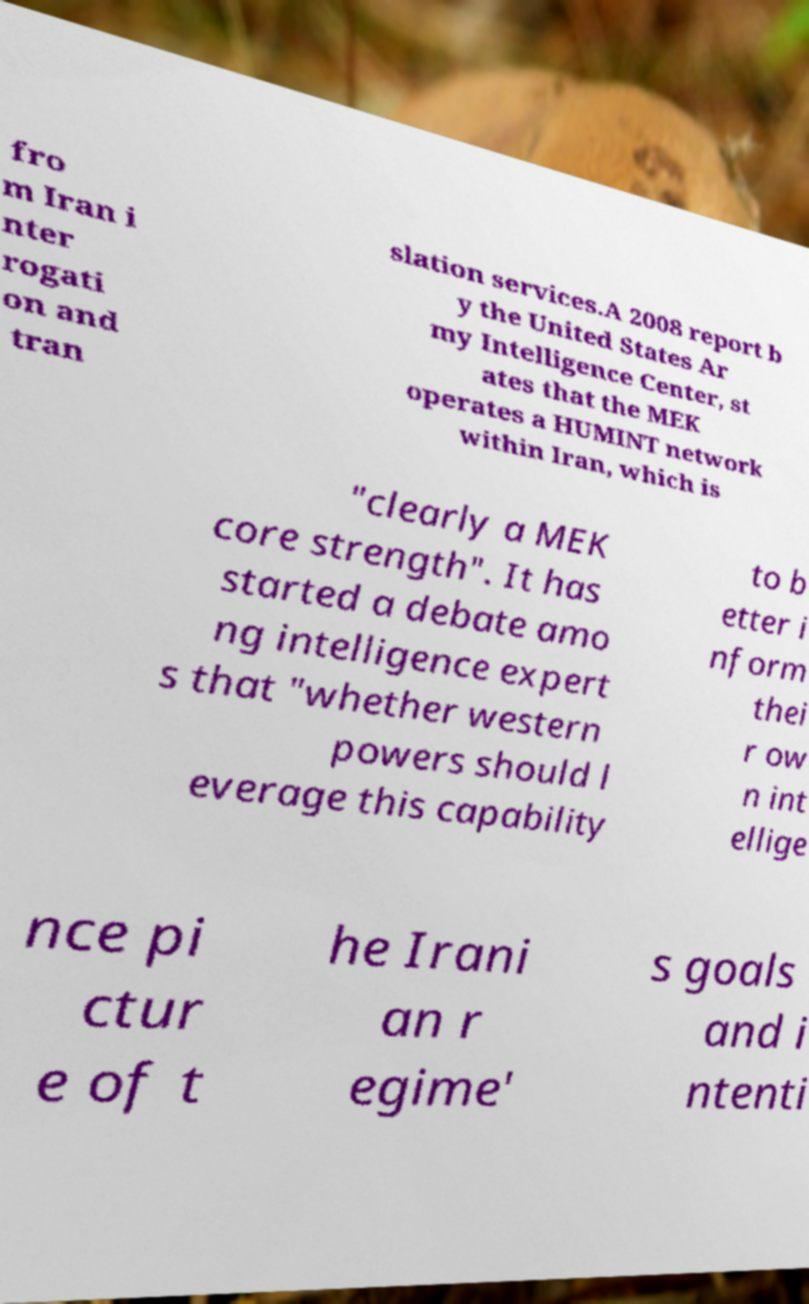I need the written content from this picture converted into text. Can you do that? fro m Iran i nter rogati on and tran slation services.A 2008 report b y the United States Ar my Intelligence Center, st ates that the MEK operates a HUMINT network within Iran, which is "clearly a MEK core strength". It has started a debate amo ng intelligence expert s that "whether western powers should l everage this capability to b etter i nform thei r ow n int ellige nce pi ctur e of t he Irani an r egime' s goals and i ntenti 